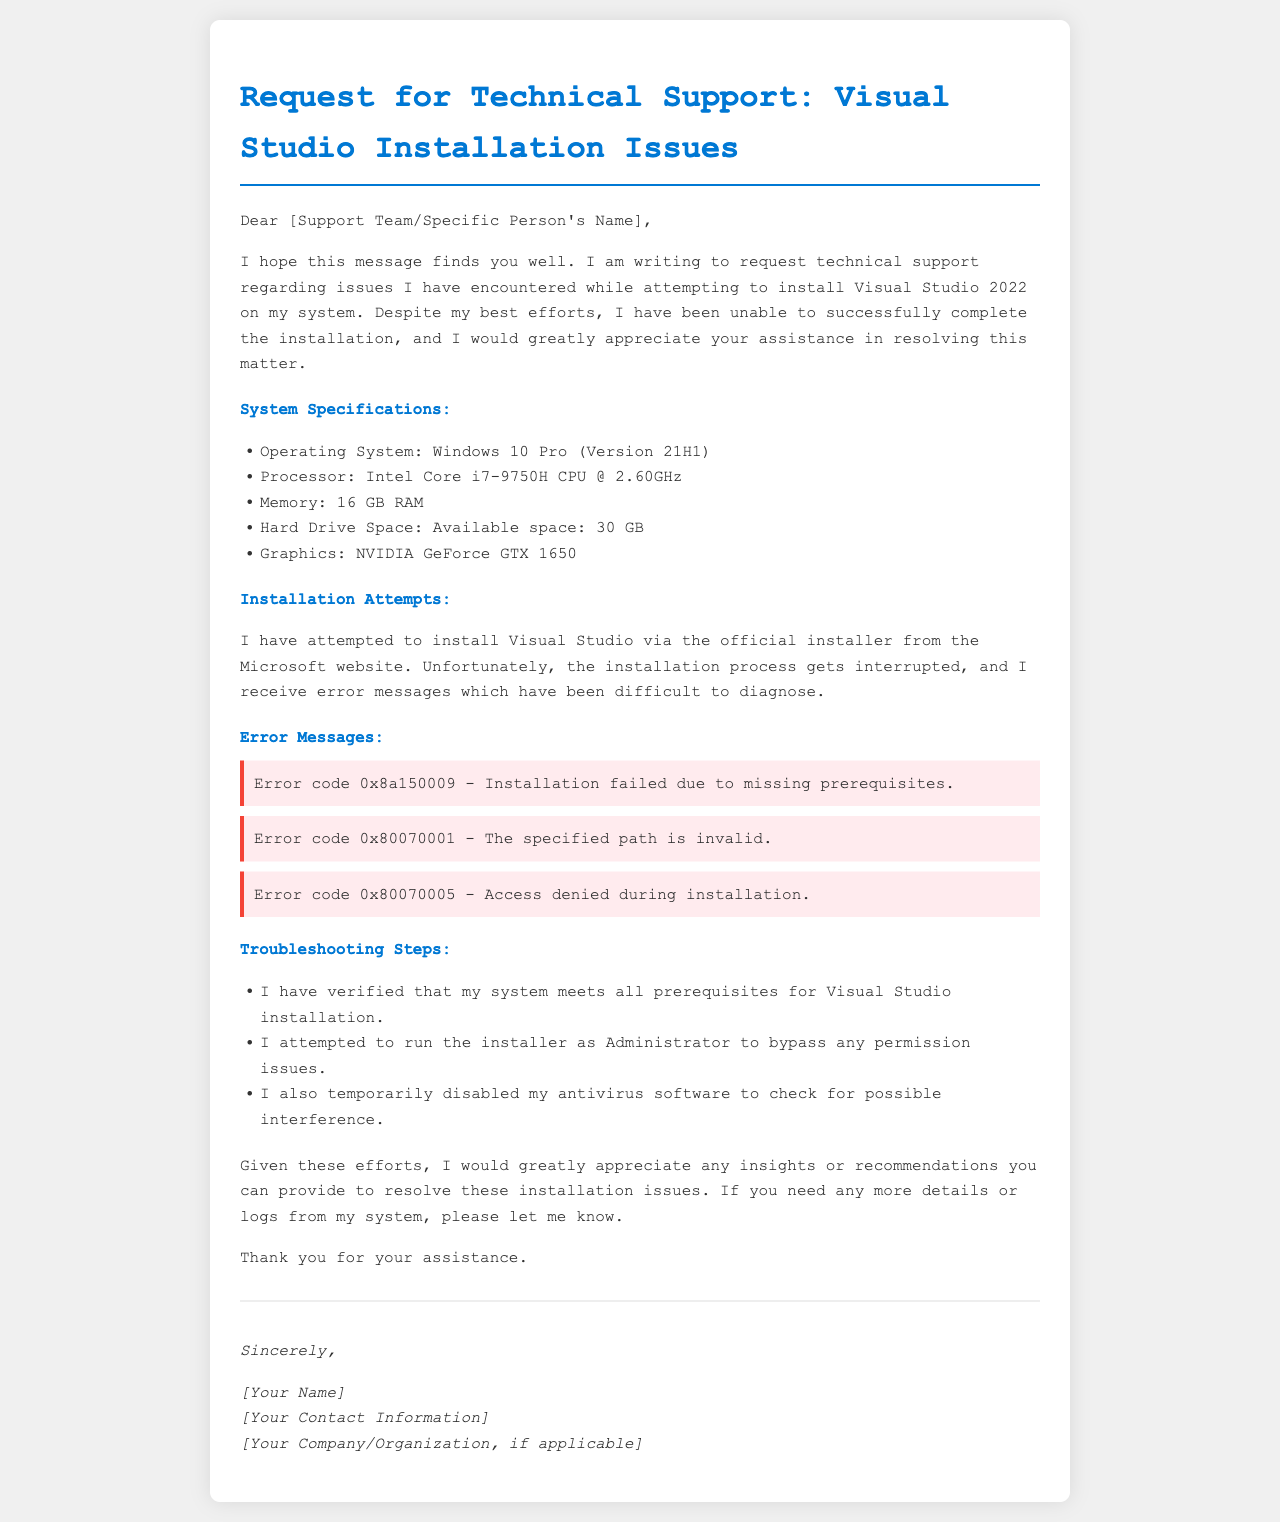What is the version of Visual Studio being installed? The document specifies that the installation is for Visual Studio 2022.
Answer: Visual Studio 2022 What is the operating system mentioned in the system specifications? According to the document, the operating system is Windows 10 Pro (Version 21H1).
Answer: Windows 10 Pro (Version 21H1) How much RAM does the system have? The document states that the system has 16 GB of RAM.
Answer: 16 GB RAM What is the first error message mentioned in the document? The first error message listed is Error code 0x8a150009 - Installation failed due to missing prerequisites.
Answer: Error code 0x8a150009 What troubleshooting step was taken regarding antivirus software? The document mentions that the antivirus software was temporarily disabled to check for possible interference.
Answer: Temporarily disabled antivirus software What type of document is this? This is a letter requesting technical support for installation issues.
Answer: Letter requesting technical support How many error codes are listed in the document? The document lists three error codes encountered during installation attempts.
Answer: Three What recommendation is requested from the support team? The author is seeking insights or recommendations to resolve the installation issues.
Answer: Insights or recommendations What processor type is specified in the system specifications? The document lists the processor as Intel Core i7-9750H CPU @ 2.60GHz.
Answer: Intel Core i7-9750H CPU @ 2.60GHz 